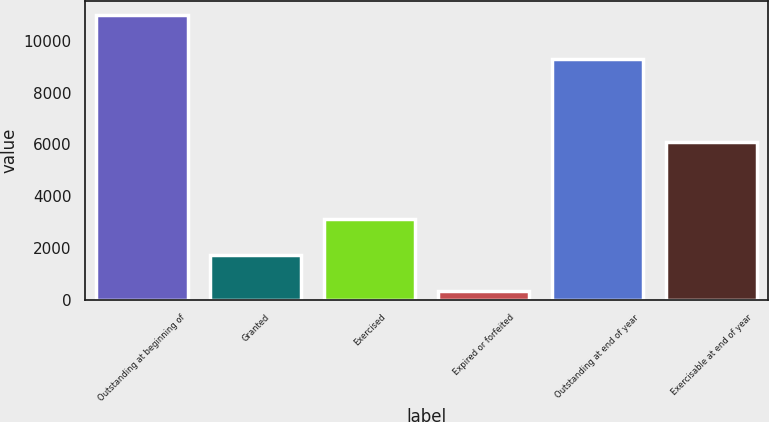Convert chart to OTSL. <chart><loc_0><loc_0><loc_500><loc_500><bar_chart><fcel>Outstanding at beginning of<fcel>Granted<fcel>Exercised<fcel>Expired or forfeited<fcel>Outstanding at end of year<fcel>Exercisable at end of year<nl><fcel>11004<fcel>1730<fcel>3126<fcel>325<fcel>9283<fcel>6094<nl></chart> 